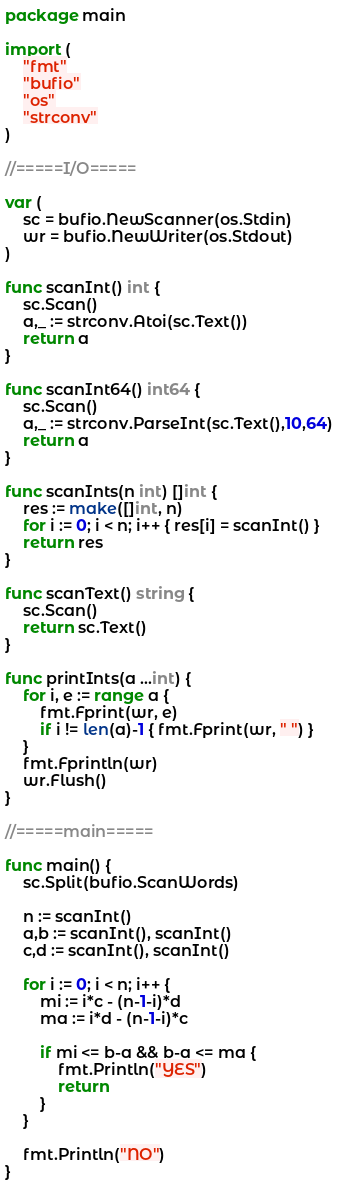Convert code to text. <code><loc_0><loc_0><loc_500><loc_500><_Go_>package main

import (
	"fmt"
	"bufio"
	"os"
	"strconv"
)

//=====I/O=====

var (
	sc = bufio.NewScanner(os.Stdin)
	wr = bufio.NewWriter(os.Stdout)
)

func scanInt() int {
	sc.Scan()
	a,_ := strconv.Atoi(sc.Text())
	return a
}

func scanInt64() int64 {
	sc.Scan()
	a,_ := strconv.ParseInt(sc.Text(),10,64)
	return a
}

func scanInts(n int) []int {
	res := make([]int, n)
	for i := 0; i < n; i++ { res[i] = scanInt() }
	return res
}

func scanText() string {
	sc.Scan()
	return sc.Text()
}

func printInts(a ...int) {
	for i, e := range a {
		fmt.Fprint(wr, e)
		if i != len(a)-1 { fmt.Fprint(wr, " ") }
	}
	fmt.Fprintln(wr)
	wr.Flush()
}

//=====main=====

func main() {
	sc.Split(bufio.ScanWords)

	n := scanInt()
	a,b := scanInt(), scanInt()
	c,d := scanInt(), scanInt()

	for i := 0; i < n; i++ {
		mi := i*c - (n-1-i)*d
		ma := i*d - (n-1-i)*c

		if mi <= b-a && b-a <= ma {
			fmt.Println("YES")
			return
		}
	}

	fmt.Println("NO")
}
</code> 